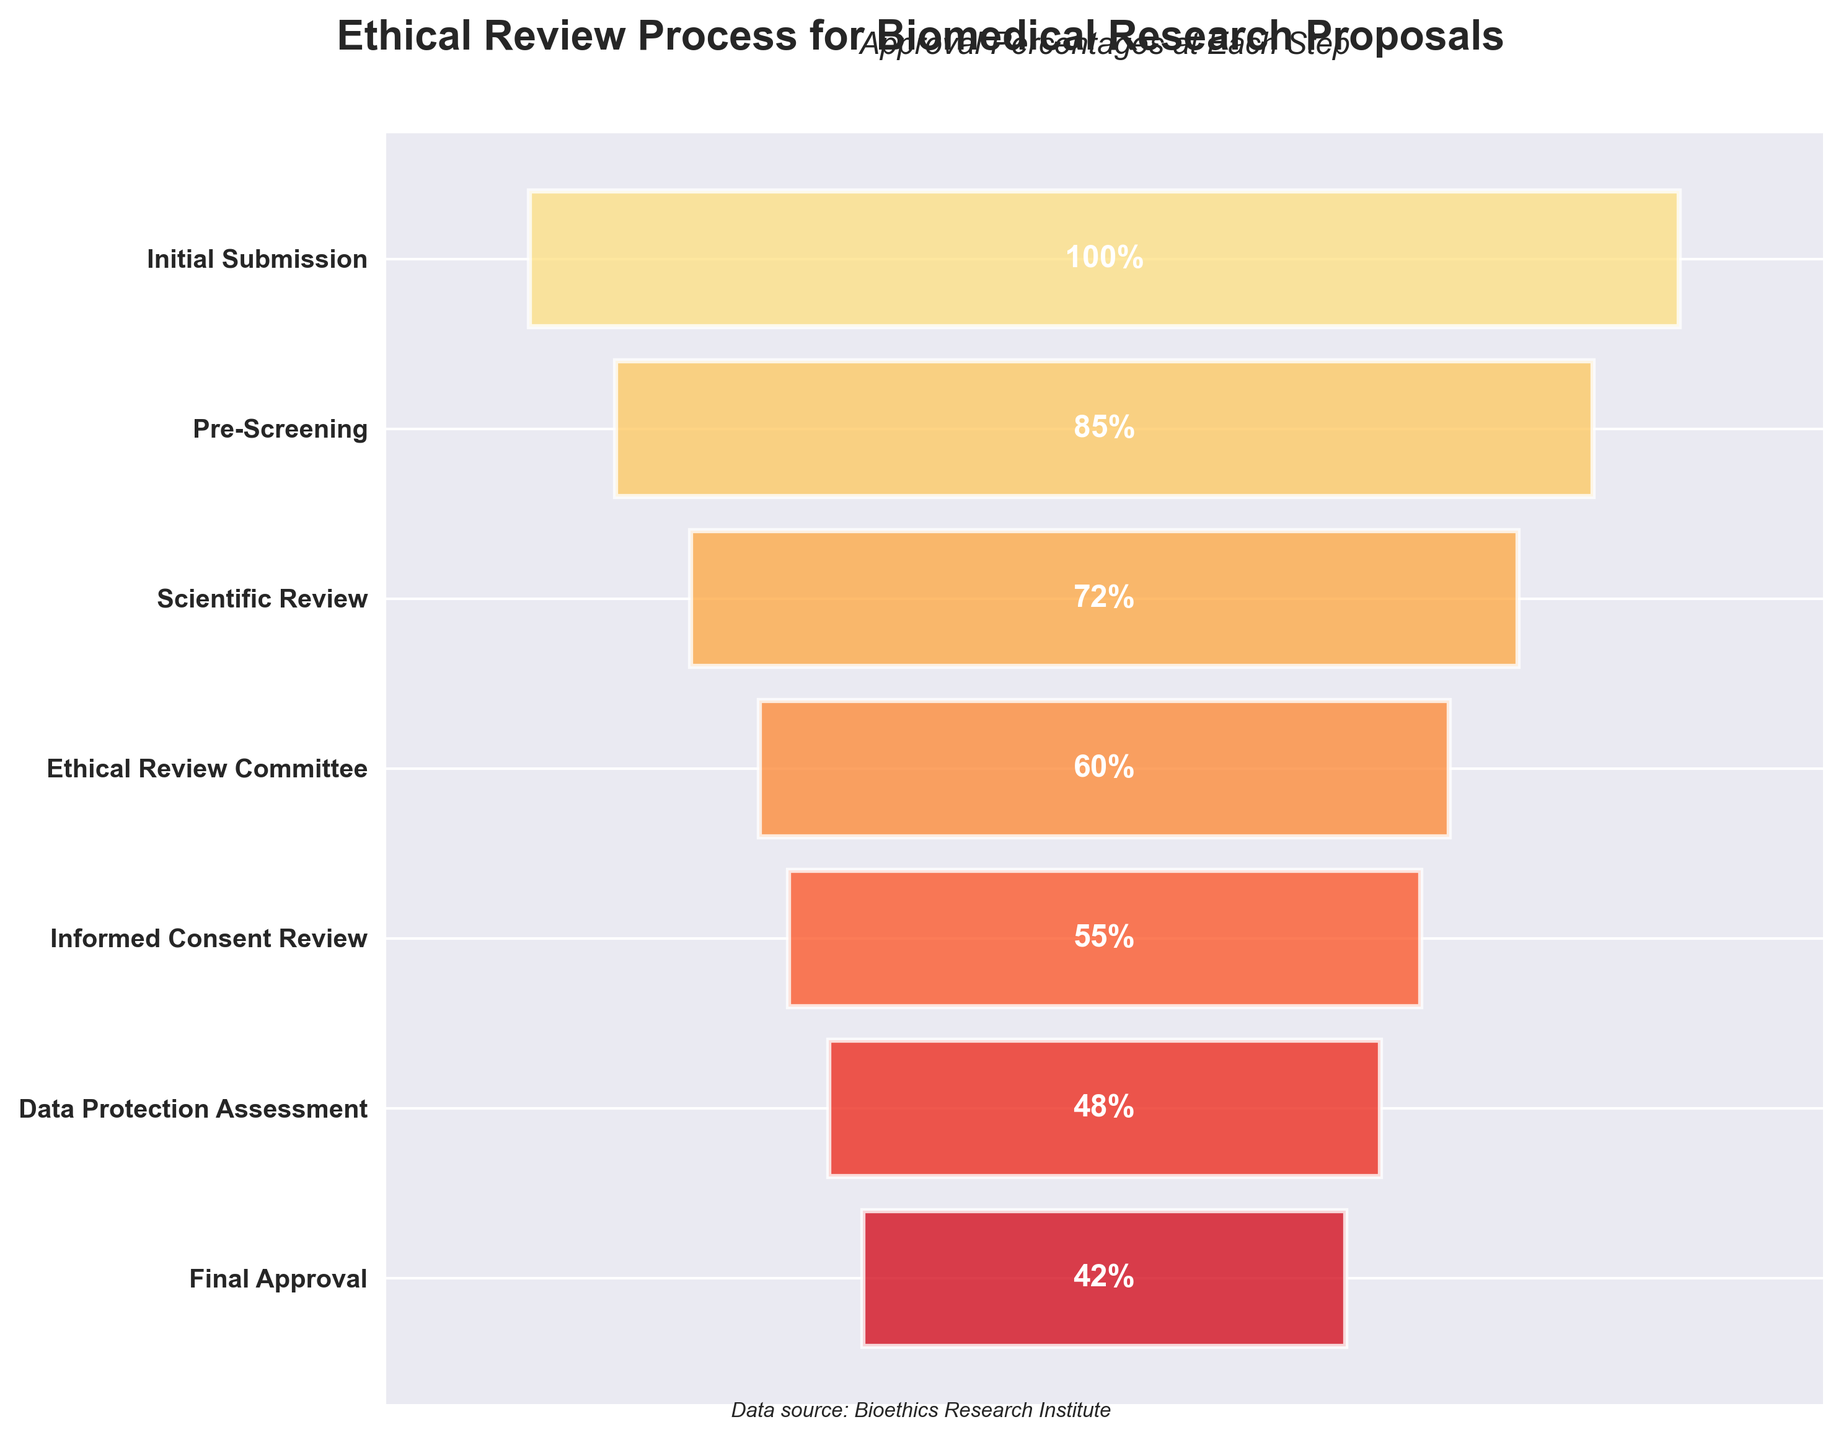What is the title of the figure? The title of the figure is usually located at the top and provides a summary of what the chart is about. In this case, it reads "Ethical Review Process for Biomedical Research Proposals".
Answer: Ethical Review Process for Biomedical Research Proposals What percentage of proposals pass the Pre-Screening step? To find this, look at the y-axis for the label "Pre-Screening" and read the percentage value associated with it.
Answer: 85% Which step has the lowest approval percentage? Look through all the labeled steps on the y-axis and identify which one has the smallest percentage next to it. The "Final Approval" step has the lowest approval percentage, which is 42%.
Answer: Final Approval How many steps are there in the ethical review process? Count the number of distinct steps listed on the y-axis. Each bar represents a step in the process. There are seven distinct steps.
Answer: Seven What is the difference in approval percentages between the Informed Consent Review and Ethical Review Committee steps? Identify the percentages for both the "Informed Consent Review" (55%) and "Ethical Review Committee" (60%). Subtract the smaller percentage from the larger one. 60% - 55% = 5%.
Answer: 5% What is the average approval percentage across all steps? To find the average, sum up all the approval percentages and divide by the number of steps. (100 + 85 + 72 + 60 + 55 + 48 + 42) / 7 = 462 / 7 ≈ 66%.
Answer: 66% Which step sees the highest drop in approval percentage from the previous step, and what is this drop? Calculate the differences between consecutive steps' approval percentages and determine which difference is the highest. The drop from "Scientific Review" (72%) to "Ethical Review Committee" (60%) is the largest, which is 72% - 60% = 12%.
Answer: Scientific Review to Ethical Review Committee, 12% What is the approval percentage for the Data Protection Assessment step? Find the "Data Protection Assessment" step label on the y-axis and read the percentage value associated with it.
Answer: 48% Are there any steps where the approval percentage is over 80%? If so, which ones? Look for steps with associated percentages above 80%. Both "Initial Submission" (100%) and "Pre-Screening" (85%) meet this criterion.
Answer: Initial Submission, Pre-Screening Compare the approval percentages at the start and the end of the process. What is the difference between the Initial Submission and Final Approval percentages? Identify the percentages for both the "Initial Submission" (100%) and "Final Approval" (42%). Subtract the "Final Approval" percentage from the "Initial Submission" percentage. 100% - 42% = 58%.
Answer: 58% 